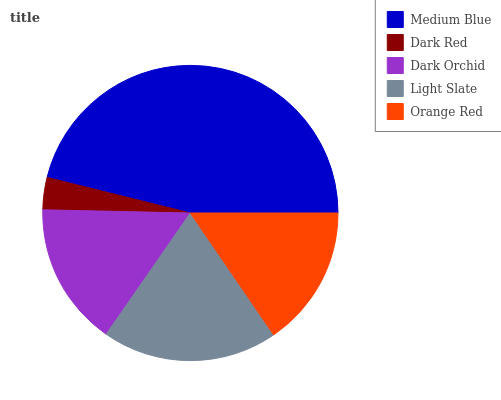Is Dark Red the minimum?
Answer yes or no. Yes. Is Medium Blue the maximum?
Answer yes or no. Yes. Is Dark Orchid the minimum?
Answer yes or no. No. Is Dark Orchid the maximum?
Answer yes or no. No. Is Dark Orchid greater than Dark Red?
Answer yes or no. Yes. Is Dark Red less than Dark Orchid?
Answer yes or no. Yes. Is Dark Red greater than Dark Orchid?
Answer yes or no. No. Is Dark Orchid less than Dark Red?
Answer yes or no. No. Is Dark Orchid the high median?
Answer yes or no. Yes. Is Dark Orchid the low median?
Answer yes or no. Yes. Is Dark Red the high median?
Answer yes or no. No. Is Dark Red the low median?
Answer yes or no. No. 